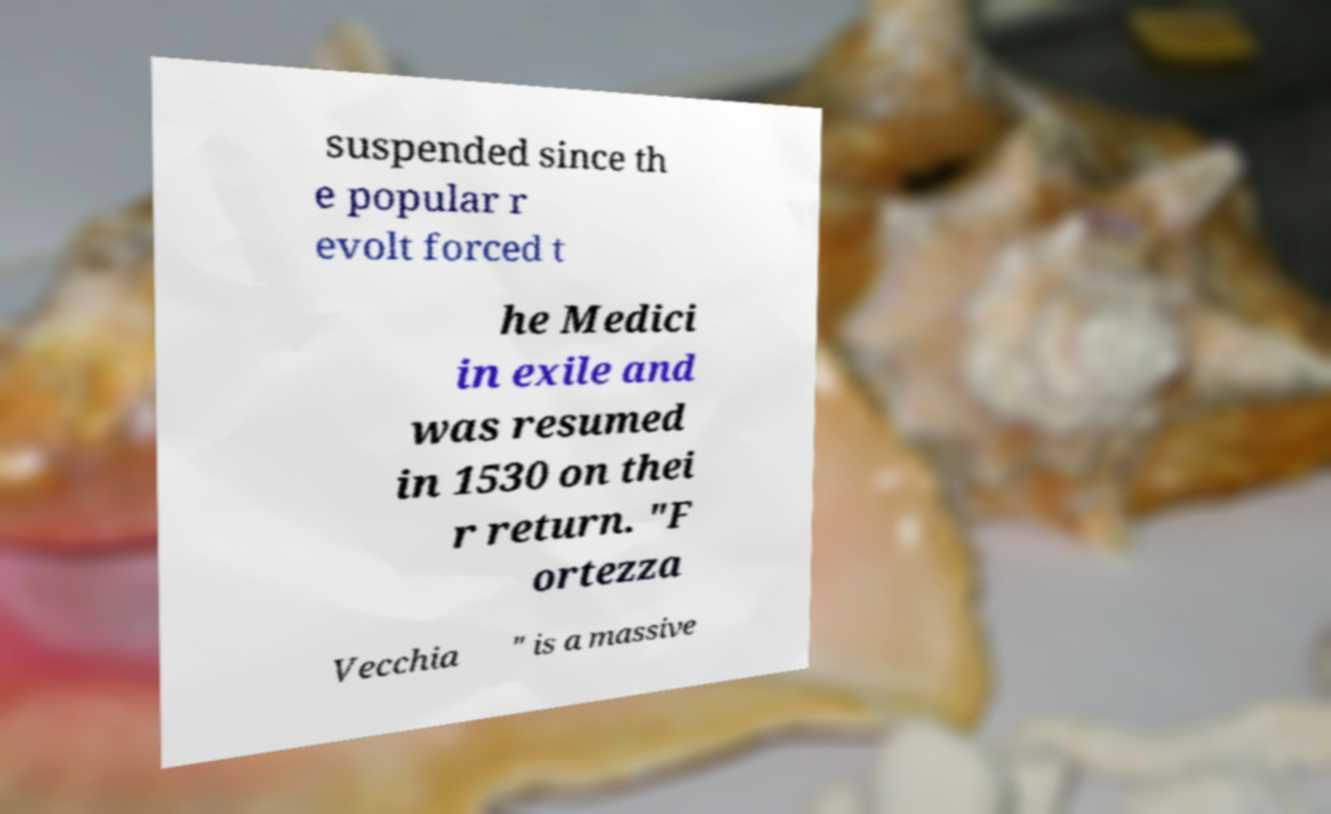Could you assist in decoding the text presented in this image and type it out clearly? suspended since th e popular r evolt forced t he Medici in exile and was resumed in 1530 on thei r return. "F ortezza Vecchia " is a massive 